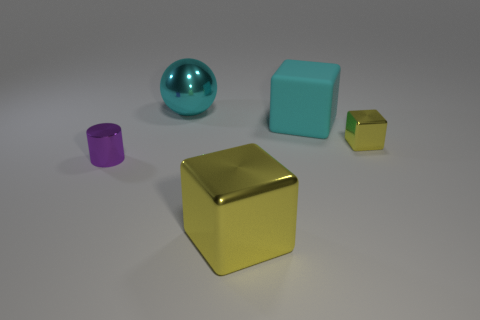Is the size of the purple metal thing the same as the cyan metallic thing?
Your answer should be very brief. No. What is the color of the big rubber thing?
Make the answer very short. Cyan. What number of things are either small shiny cylinders or small blocks?
Make the answer very short. 2. Is there a tiny purple metallic thing of the same shape as the large cyan matte object?
Your answer should be very brief. No. There is a small shiny thing that is in front of the tiny yellow object; does it have the same color as the small cube?
Keep it short and to the point. No. What shape is the tiny object on the left side of the object to the right of the big cyan block?
Your answer should be very brief. Cylinder. Is there a brown thing of the same size as the cylinder?
Offer a very short reply. No. Is the number of brown cylinders less than the number of large cyan metal balls?
Offer a terse response. Yes. There is a thing that is in front of the tiny thing left of the thing in front of the purple object; what is its shape?
Ensure brevity in your answer.  Cube. How many objects are things that are on the left side of the big cyan metallic sphere or metal things to the left of the large sphere?
Offer a terse response. 1. 